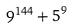Convert formula to latex. <formula><loc_0><loc_0><loc_500><loc_500>9 ^ { 1 4 4 } + 5 ^ { 9 }</formula> 